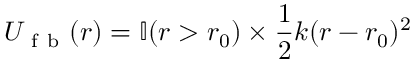Convert formula to latex. <formula><loc_0><loc_0><loc_500><loc_500>U _ { f b } ( r ) = \mathbb { I } ( r > r _ { 0 } ) \times \frac { 1 } { 2 } k ( r - r _ { 0 } ) ^ { 2 }</formula> 